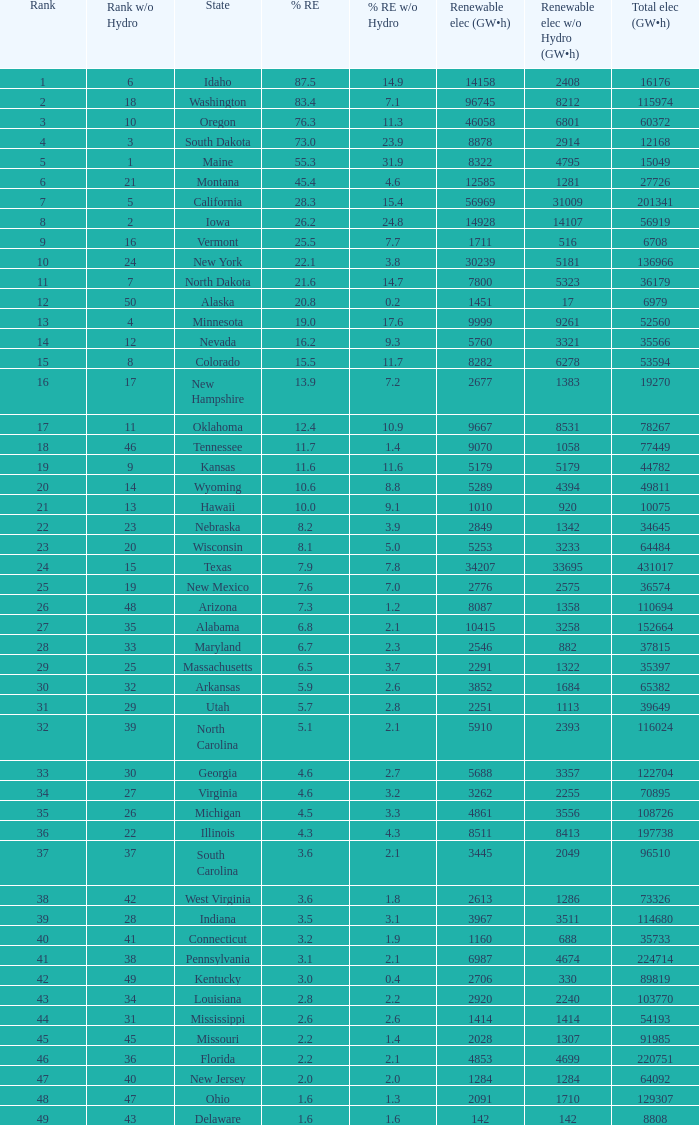Which state has 5179 (gw×h) of renewable energy without hydrogen power?wha Kansas. 